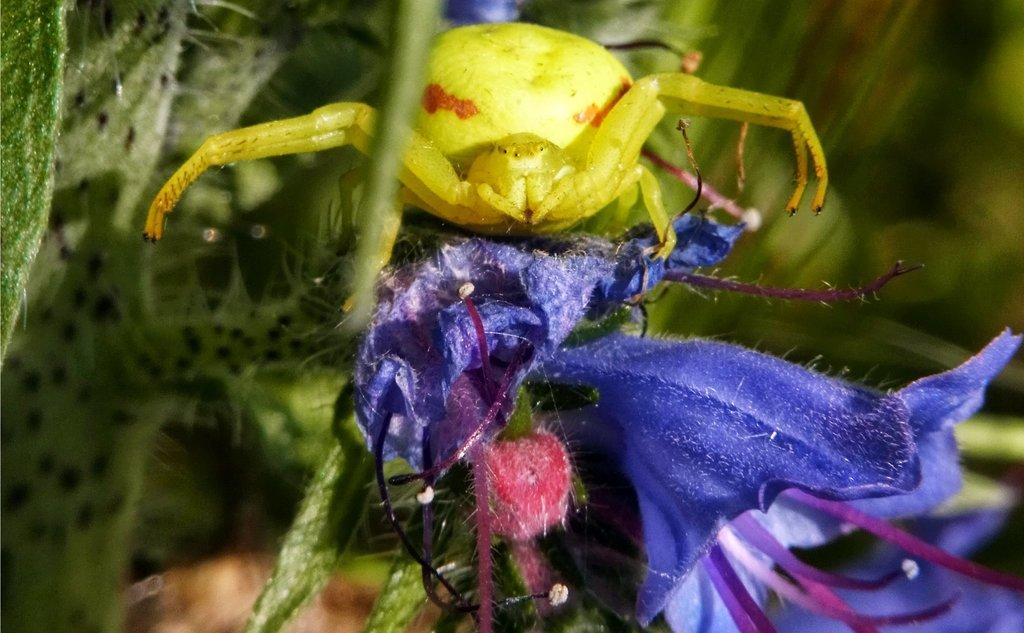What type of creature is in the image? There is an insect in the image. Where is the insect located in the image? The insect is on a flower. What type of maid is visible in the image? There is no maid present in the image; it features an insect on a flower. How does the insect change its appearance in the image? The insect does not change its appearance in the image; it remains the same throughout. 